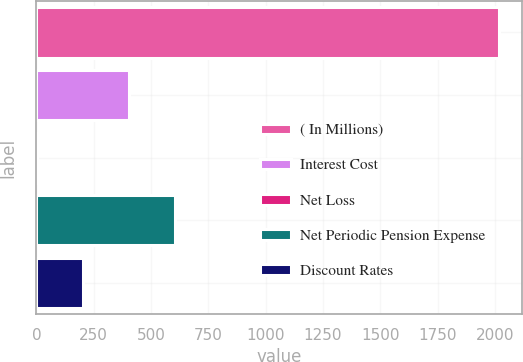Convert chart. <chart><loc_0><loc_0><loc_500><loc_500><bar_chart><fcel>( In Millions)<fcel>Interest Cost<fcel>Net Loss<fcel>Net Periodic Pension Expense<fcel>Discount Rates<nl><fcel>2016<fcel>404<fcel>1<fcel>605.5<fcel>202.5<nl></chart> 